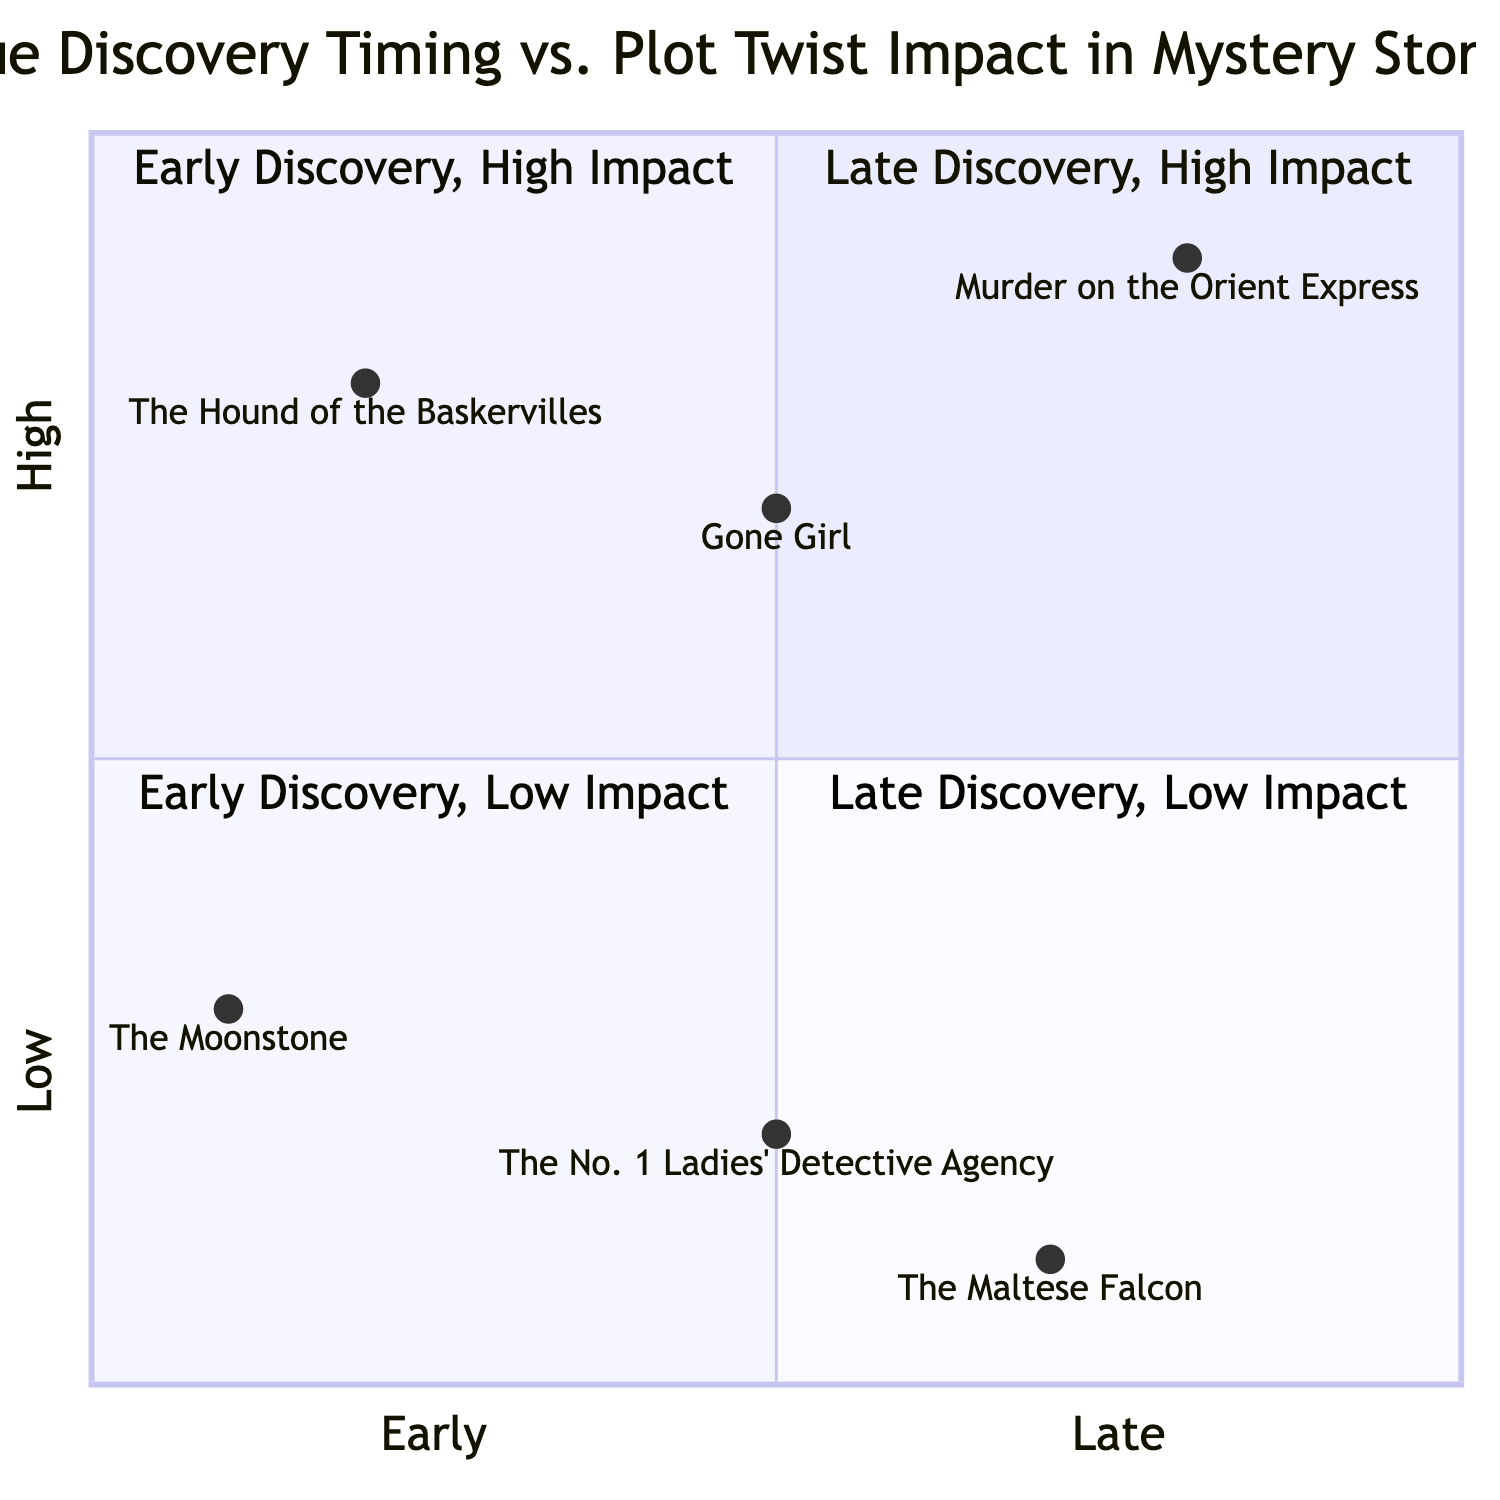What is the example story in the "Early Discovery, High Impact" quadrant? To find the answer, locate the second quadrant, which corresponds to early clue discovery and high plot twist impact. The story listed there is "The Hound of the Baskervilles".
Answer: The Hound of the Baskervilles How many stories are plotted in the "Late Discovery, Low Impact" quadrant? The fourth quadrant is examined, which represents late clue discovery and low plot twist impact. There is one story listed, which is "The Maltese Falcon".
Answer: One Which story has its key clue revealed in the "Midway Discovery, High Impact" quadrant? Navigate to the quadrant denoting midway clue discovery and high plot twist impact. The relevant story is "Gone Girl" in that quadrant.
Answer: Gone Girl What is the key clue of "Murder on the Orient Express"? Identify the story "Murder on the Orient Express" in the diagram. The corresponding key clue mentioned is "All suspects together planned the murder."
Answer: All suspects together planned the murder Which quadrant contains stories with **low** plot twist impact? Review the quadrants to determine which two occupy the low plot twist impact (third and fourth quadrants). The third quadrant includes "The Moonstone" and "The No. 1 Ladies' Detective Agency", while the fourth includes "The Maltese Falcon".
Answer: Third and Fourth Quadrants How does "The Maltese Falcon" compare in timing and impact to "Gone Girl"? Analyze the positions of both stories. "The Maltese Falcon" is in the "Late Discovery, Low Impact" quadrant, while "Gone Girl" is in the "Midway Discovery, High Impact" quadrant, indicating that "The Maltese Falcon" has a later discovery with less impact compared to "Gone Girl".
Answer: Later and lower impact What is the key clue for the story in the "Early Discovery, Low Impact" quadrant? Locate the story in the third quadrant representing early discovery with low impact. The key clue identified is "The stained nightgown of Rachel Verinder."
Answer: The stained nightgown of Rachel Verinder Which story shows the highest impact in the "Late Discovery" category? In the quadrant where late discovery is present, there is a comparison between "Murder on the Orient Express" and "The Maltese Falcon". "Murder on the Orient Express" has the higher impact according to the diagram.
Answer: Murder on the Orient Express How many total stories are represented in the diagram? Count the total number of stories provided across the quadrants. There are six stories listed in total: "The Hound of the Baskervilles", "The Moonstone", "Murder on the Orient Express", "The Maltese Falcon", "Gone Girl", and "The No. 1 Ladies' Detective Agency".
Answer: Six 